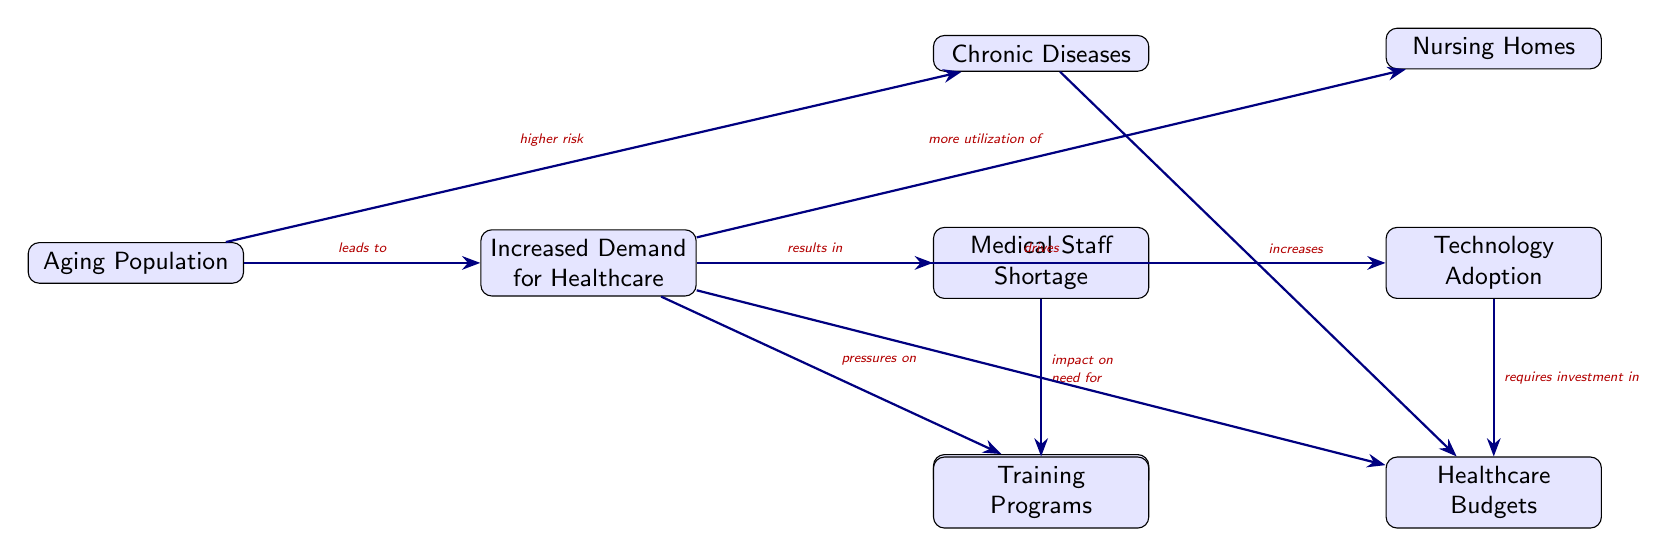What is the primary node in the diagram? The primary node, indicating the main topic of the diagram, is "Aging Population." It serves as the starting point for the various impacts and consequences listed in the diagram.
Answer: Aging Population How many total nodes are in the diagram? By counting each distinct box in the diagram, we identify a total of 8 nodes that represent different aspects or consequences of the aging population on healthcare resources.
Answer: 8 What does the "Aging Population" lead to? The "Aging Population" leads to "Increased Demand for Healthcare," showing a direct relationship between the aging demographic and the growing need for health services.
Answer: Increased Demand for Healthcare Which node focuses on financial implications? The node "Healthcare Budgets" addresses the financial ramifications of the increased demand on resources resulting from the aging population and chronic diseases.
Answer: Healthcare Budgets What is required for technology adoption according to the diagram? Technology adoption requires investment in the "Healthcare Budgets," highlighting the financial necessity that comes with incorporating new technologies in response to aging population demands.
Answer: Investment in Budget What is the relationship between "Increased Demand for Healthcare" and "Medical Staff Shortage"? The relationship indicates that the "Increased Demand for Healthcare" results in a "Medical Staff Shortage," showcasing how higher demand can lead to a lack of available healthcare workers.
Answer: Results in Medical Staff Shortage How does "Chronic Diseases" affect the "Healthcare Budgets"? "Chronic Diseases" increases the "Healthcare Budgets," indicating that higher rates of chronic conditions among the aging population contribute to greater financial strain on healthcare funding.
Answer: Increases Budget What does increased demand for healthcare drive? Increased demand for healthcare drives the need for "Technology Adoption," showing that as the demand rises, there is a push towards utilizing technological innovations to meet those needs.
Answer: Technology Adoption Which node is directly impacted by both "Increased Demand for Healthcare" and "Chronic Diseases"? The node "Healthcare Budgets" is directly impacted by both "Increased Demand for Healthcare" and "Chronic Diseases," underlining the financial challenges they pose.
Answer: Healthcare Budgets 